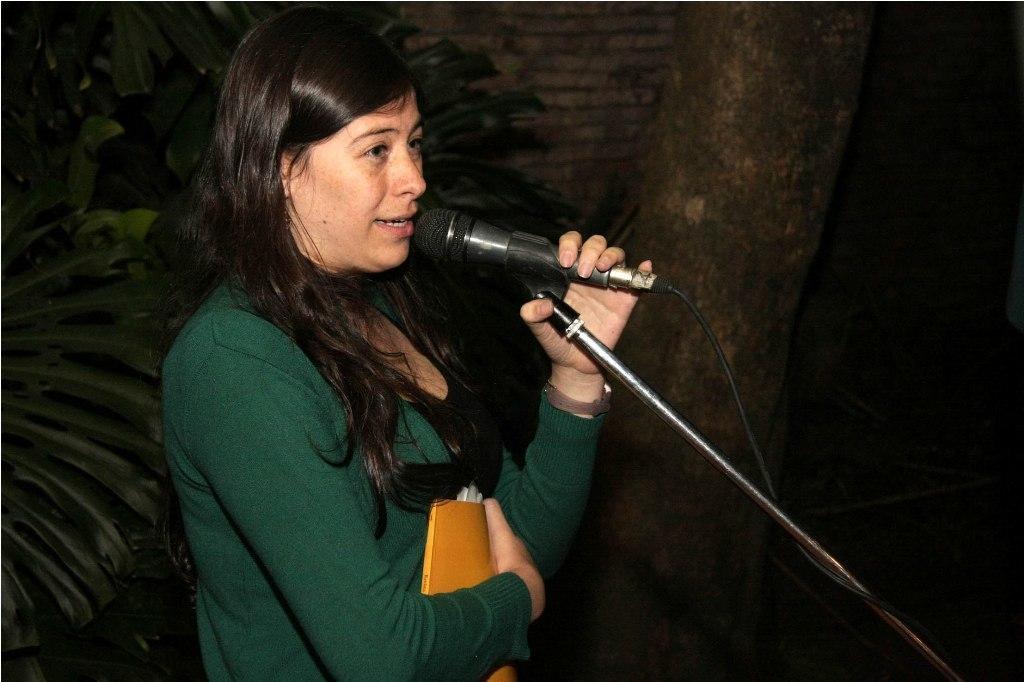Could you give a brief overview of what you see in this image? In this image I see a woman who is holding a book and the mic in her hands, In the background I see tree and the plants. 